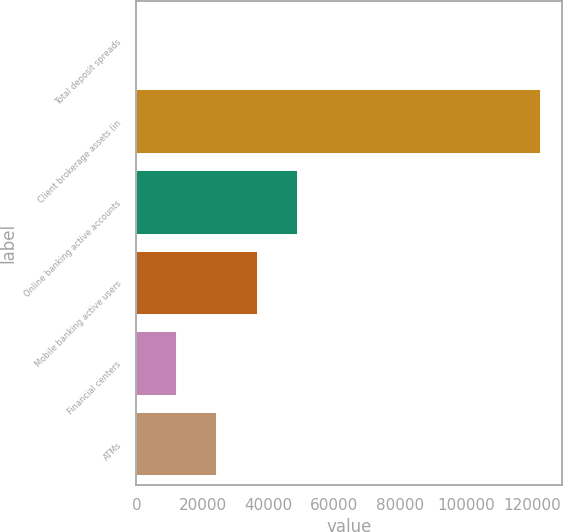Convert chart to OTSL. <chart><loc_0><loc_0><loc_500><loc_500><bar_chart><fcel>Total deposit spreads<fcel>Client brokerage assets (in<fcel>Online banking active accounts<fcel>Mobile banking active users<fcel>Financial centers<fcel>ATMs<nl><fcel>1.62<fcel>122721<fcel>49089.4<fcel>36817.4<fcel>12273.6<fcel>24545.5<nl></chart> 